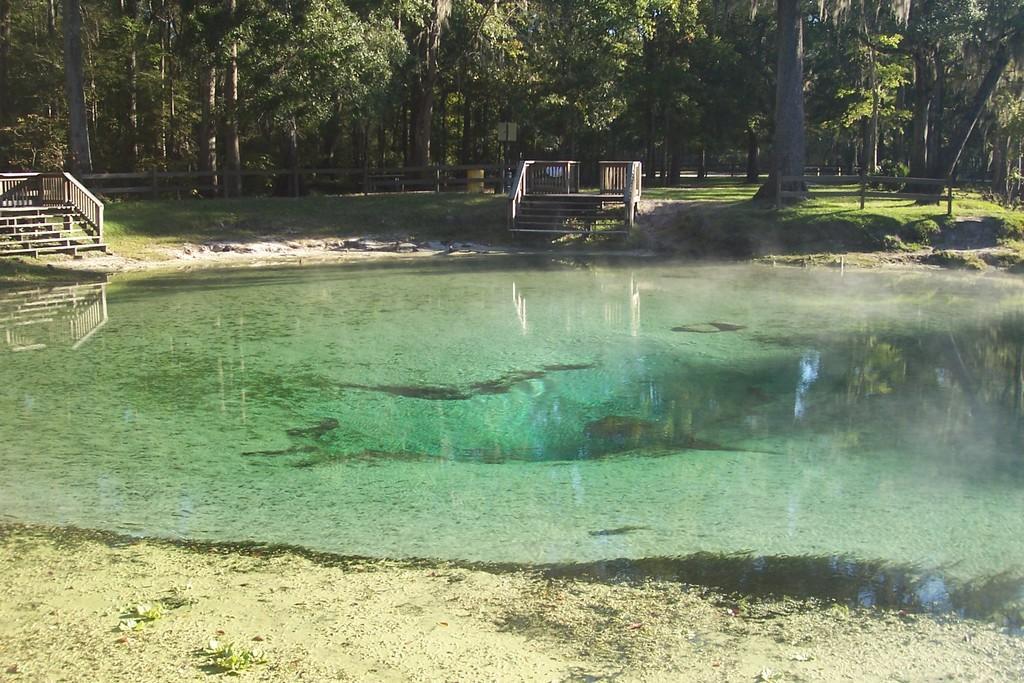In one or two sentences, can you explain what this image depicts? In this image at the bottom, there is water and land. In the middle there are staircases, grass, trees and benches, fence. 